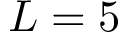<formula> <loc_0><loc_0><loc_500><loc_500>L = 5</formula> 